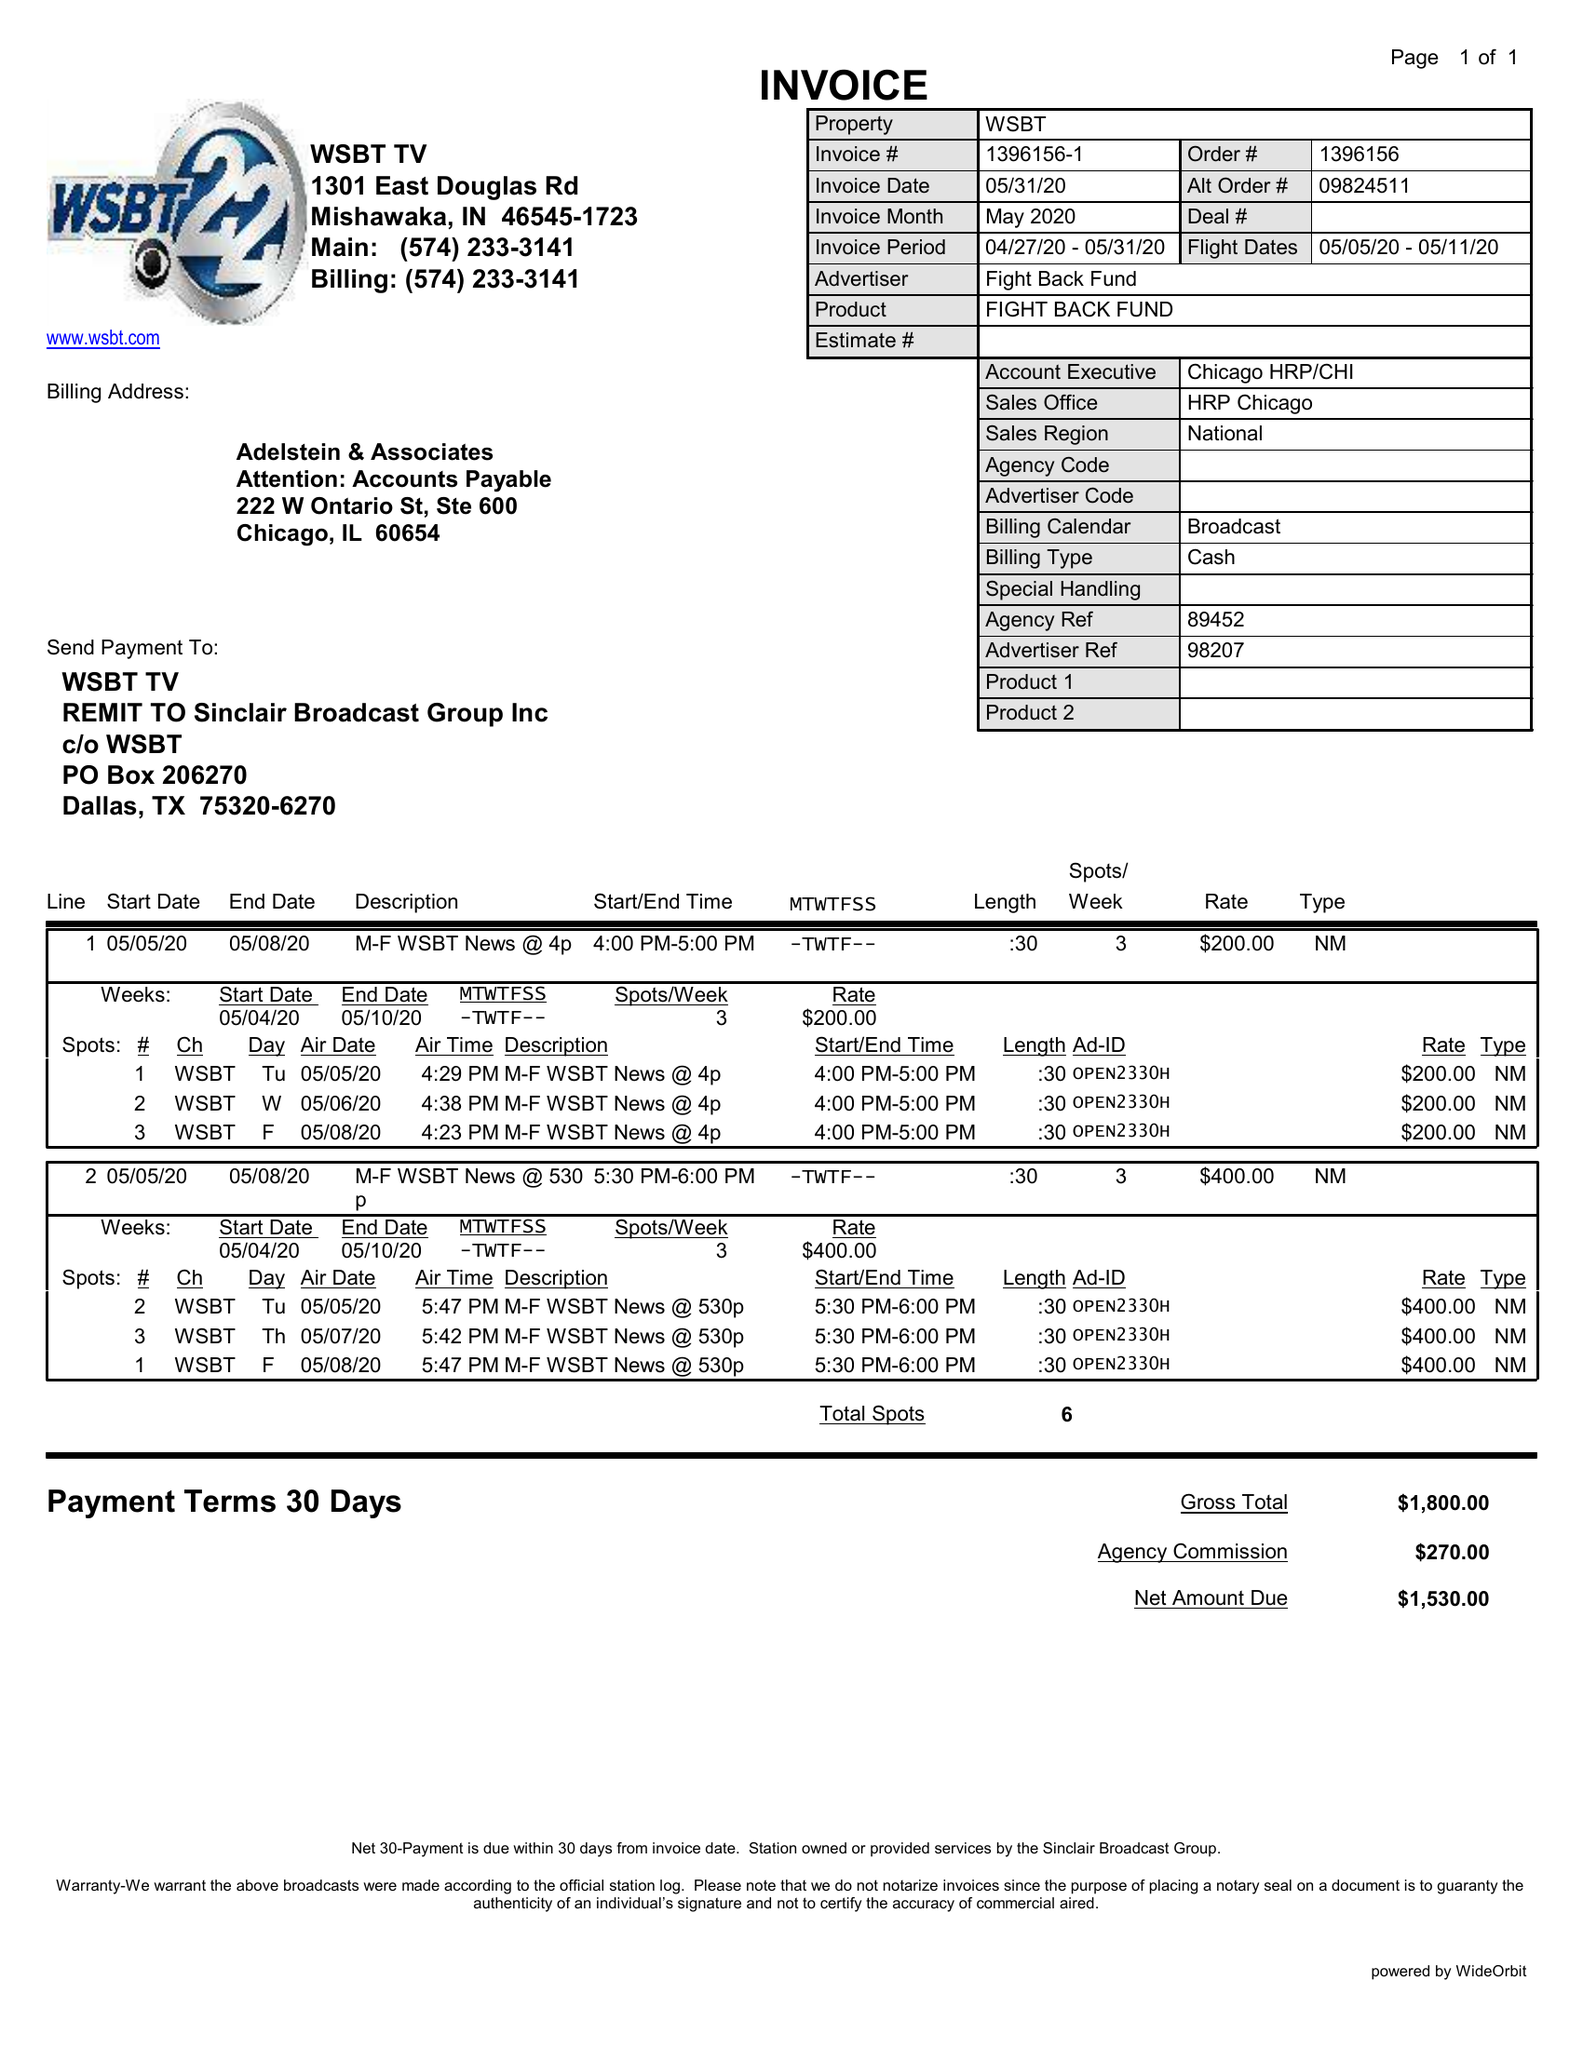What is the value for the advertiser?
Answer the question using a single word or phrase. FIGHT BACK FUND 